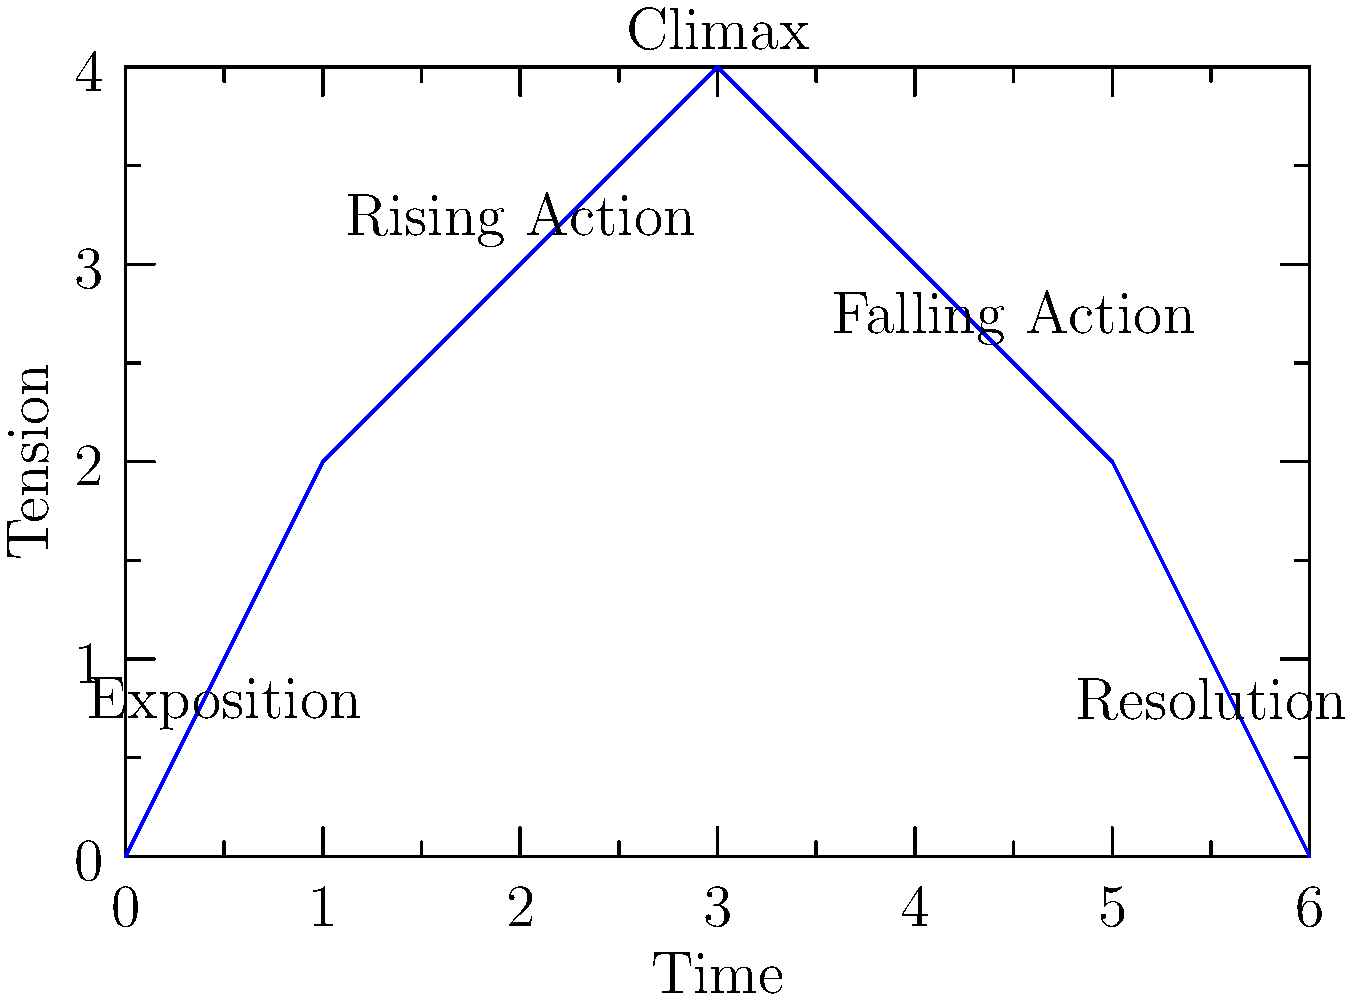In the plot diagram above, which section of the novel's structure typically contains the highest point of tension and the turning point of the story? To answer this question, we need to analyze the different sections of the plot diagram:

1. Exposition: This is the beginning of the story, where characters and setting are introduced. It has low tension.

2. Rising Action: This section shows increasing tension as conflicts develop and complications arise.

3. Climax: This is the highest point on the diagram, representing the peak of tension and the turning point of the story.

4. Falling Action: After the climax, tension begins to decrease as conflicts start to resolve.

5. Resolution: The final section where loose ends are tied up and tension returns to a low level.

The question asks for the section with the highest point of tension and the turning point of the story. By examining the diagram, we can see that the peak of the curve corresponds to the "Climax" section. This matches our understanding of narrative structure, where the climax represents the moment of highest tension and the critical turning point in the plot.
Answer: Climax 